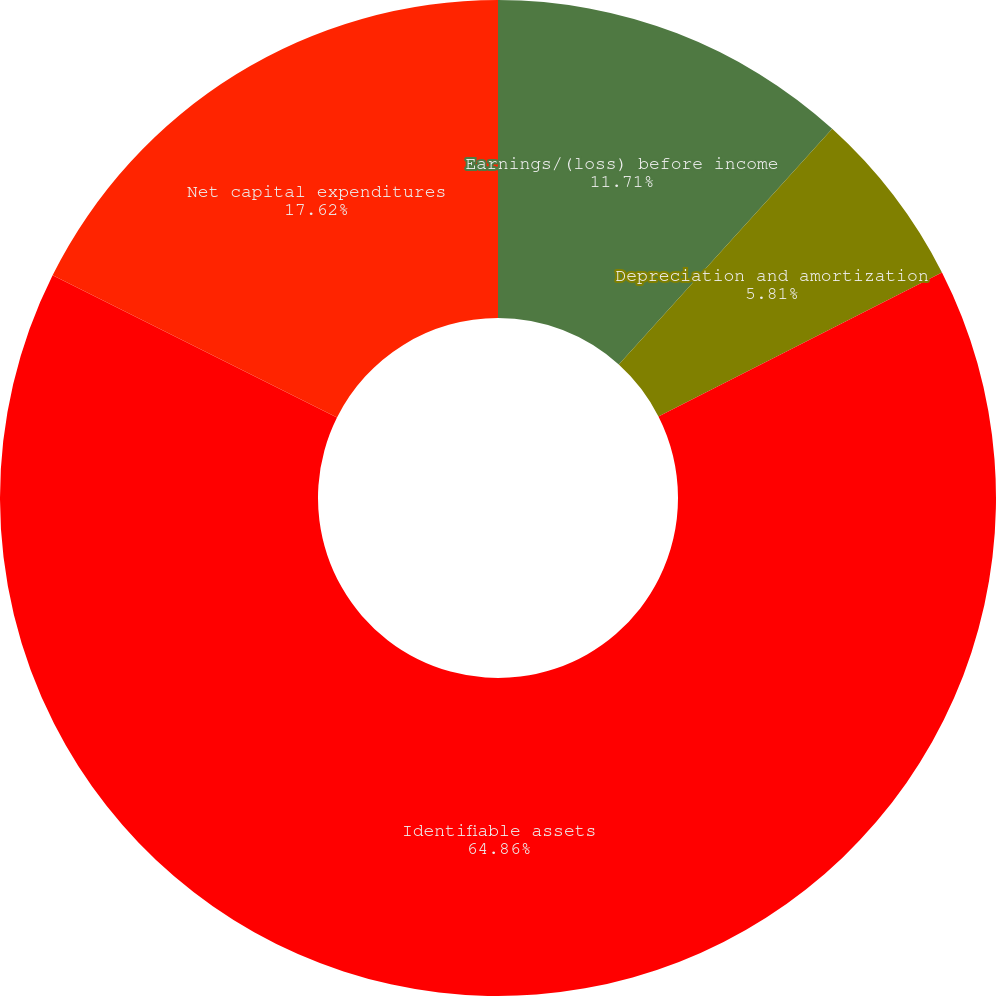<chart> <loc_0><loc_0><loc_500><loc_500><pie_chart><fcel>Earnings/(loss) before income<fcel>Depreciation and amortization<fcel>Identifiable assets<fcel>Net capital expenditures<nl><fcel>11.71%<fcel>5.81%<fcel>64.87%<fcel>17.62%<nl></chart> 